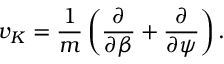<formula> <loc_0><loc_0><loc_500><loc_500>v _ { K } = \frac { 1 } { m } \left ( \frac { \partial } { \partial \beta } + \frac { \partial } { \partial \psi } \right ) .</formula> 